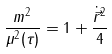Convert formula to latex. <formula><loc_0><loc_0><loc_500><loc_500>\frac { m ^ { 2 } } { \mu ^ { 2 } ( \tau ) } = 1 + \frac { \dot { \vec { r } } ^ { 2 } } { 4 }</formula> 